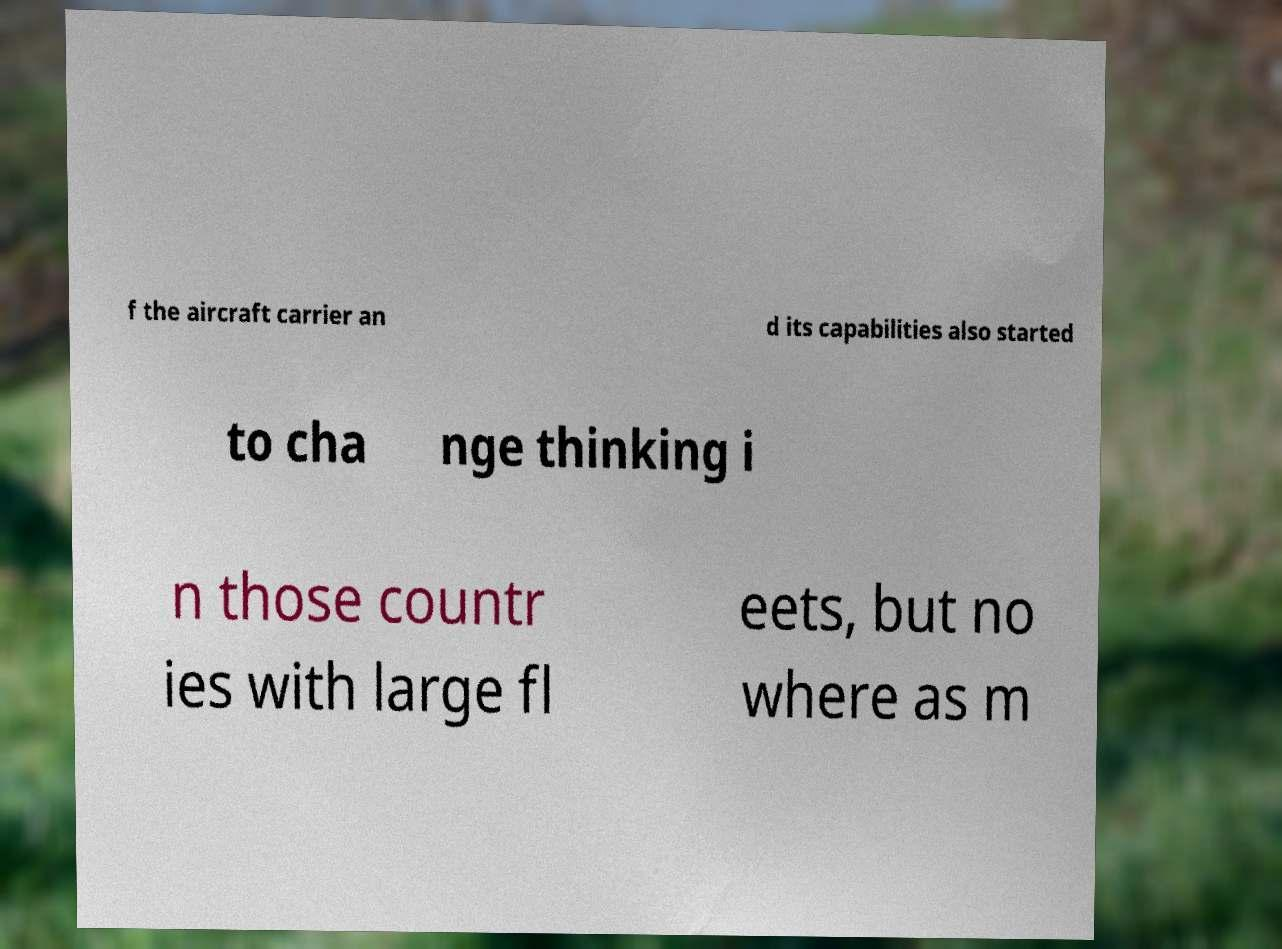What messages or text are displayed in this image? I need them in a readable, typed format. f the aircraft carrier an d its capabilities also started to cha nge thinking i n those countr ies with large fl eets, but no where as m 